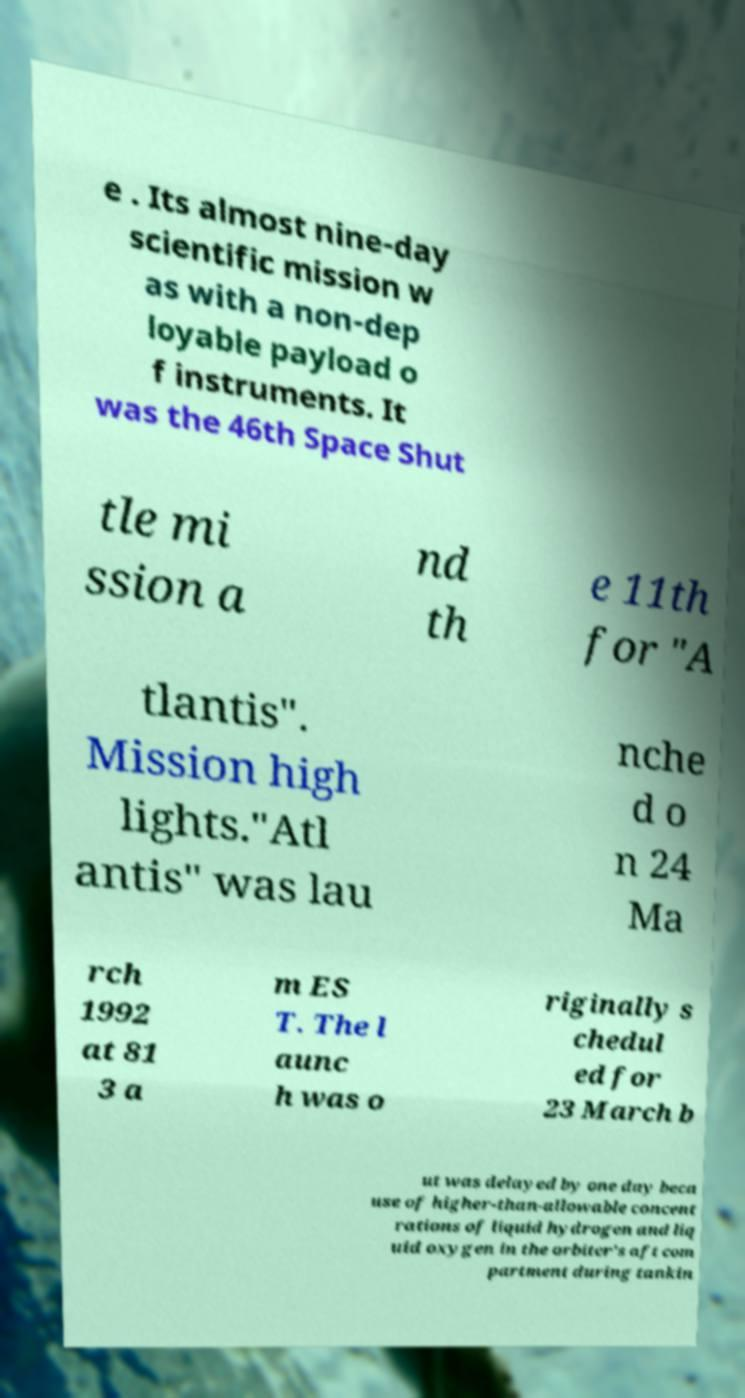For documentation purposes, I need the text within this image transcribed. Could you provide that? e . Its almost nine-day scientific mission w as with a non-dep loyable payload o f instruments. It was the 46th Space Shut tle mi ssion a nd th e 11th for "A tlantis". Mission high lights."Atl antis" was lau nche d o n 24 Ma rch 1992 at 81 3 a m ES T. The l aunc h was o riginally s chedul ed for 23 March b ut was delayed by one day beca use of higher-than-allowable concent rations of liquid hydrogen and liq uid oxygen in the orbiter's aft com partment during tankin 